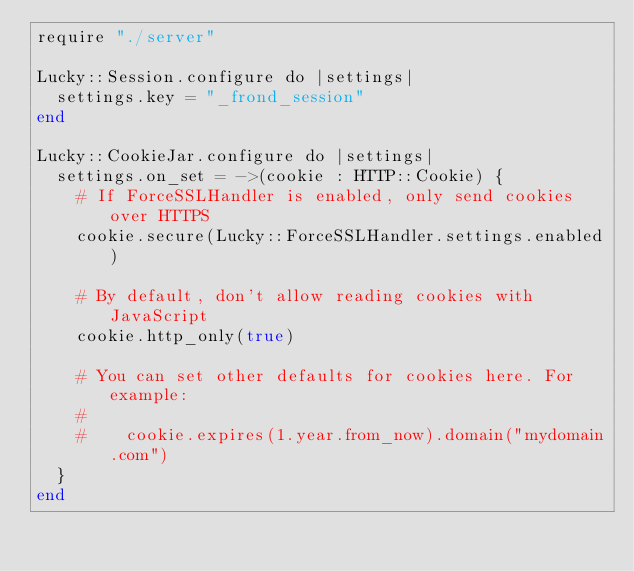<code> <loc_0><loc_0><loc_500><loc_500><_Crystal_>require "./server"

Lucky::Session.configure do |settings|
  settings.key = "_frond_session"
end

Lucky::CookieJar.configure do |settings|
  settings.on_set = ->(cookie : HTTP::Cookie) {
    # If ForceSSLHandler is enabled, only send cookies over HTTPS
    cookie.secure(Lucky::ForceSSLHandler.settings.enabled)

    # By default, don't allow reading cookies with JavaScript
    cookie.http_only(true)

    # You can set other defaults for cookies here. For example:
    #
    #    cookie.expires(1.year.from_now).domain("mydomain.com")
  }
end
</code> 